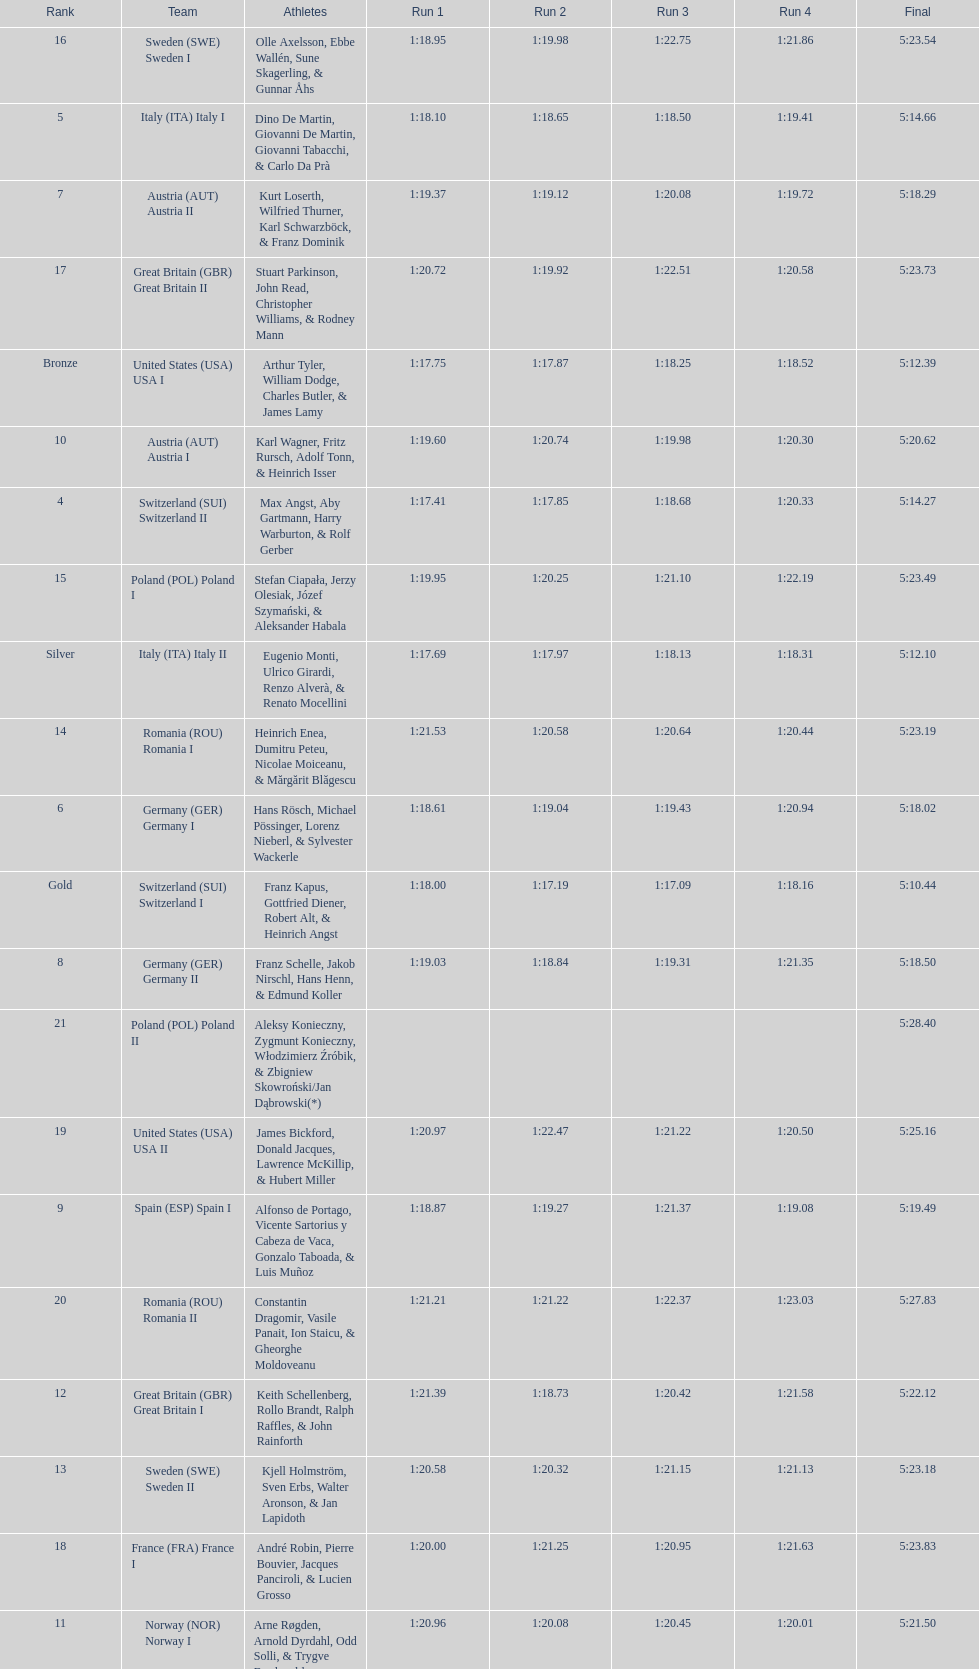Who is the previous team to italy (ita) italy ii? Switzerland (SUI) Switzerland I. 